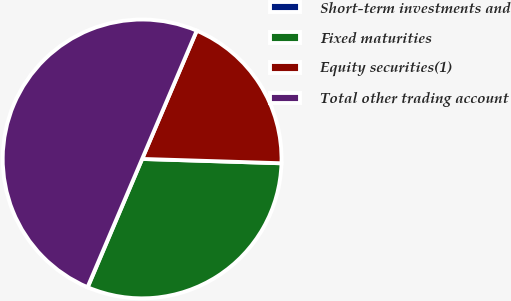<chart> <loc_0><loc_0><loc_500><loc_500><pie_chart><fcel>Short-term investments and<fcel>Fixed maturities<fcel>Equity securities(1)<fcel>Total other trading account<nl><fcel>0.03%<fcel>30.88%<fcel>19.09%<fcel>50.0%<nl></chart> 